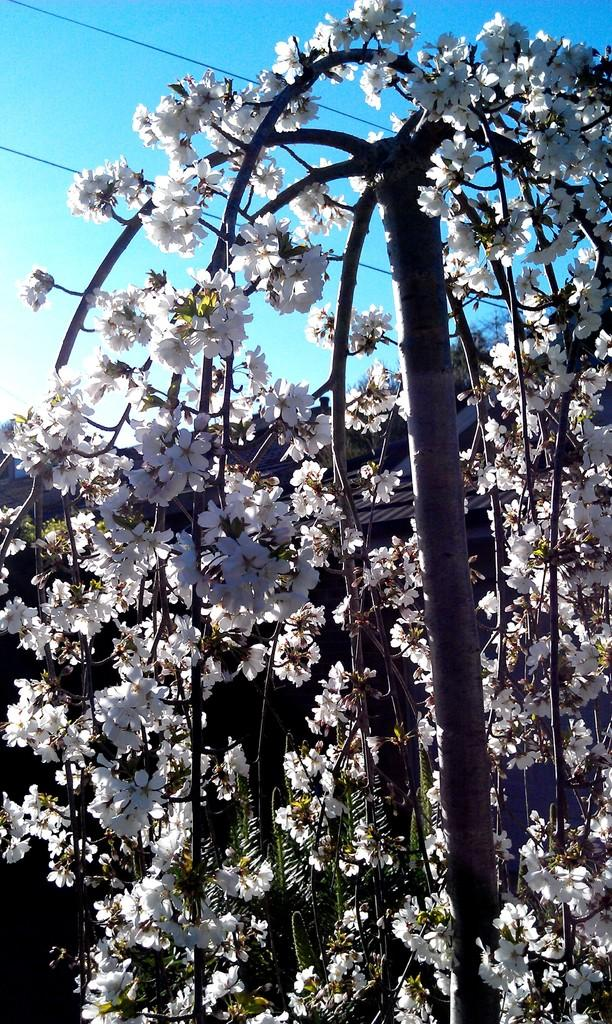What is the main subject of the picture? The main subject of the picture is a tree. What is covering the tree in the picture? The tree is covered with flowers. What type of tooth can be seen hanging from the tree in the image? There is no tooth present in the image; the tree is covered with flowers. What material is the brass used for in the image? There is no brass present in the image. 